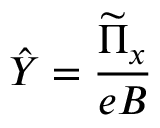<formula> <loc_0><loc_0><loc_500><loc_500>\hat { Y } = \frac { \widetilde { \Pi } _ { x } } { e B }</formula> 